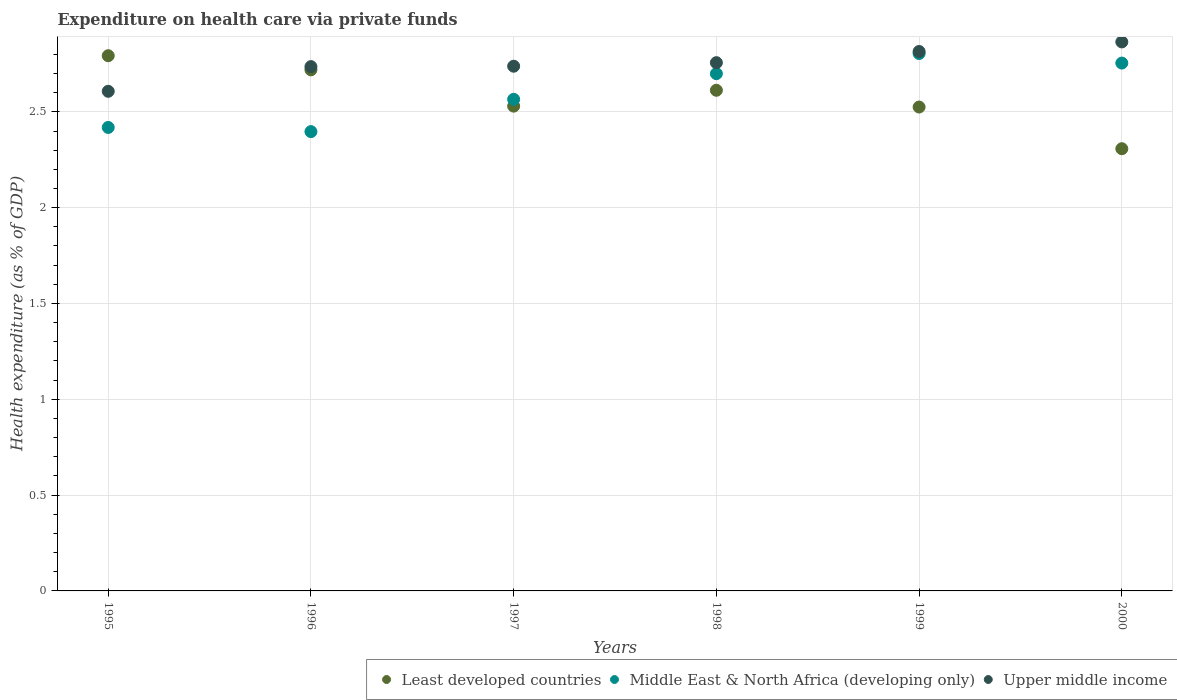What is the expenditure made on health care in Least developed countries in 1997?
Your answer should be compact. 2.53. Across all years, what is the maximum expenditure made on health care in Middle East & North Africa (developing only)?
Ensure brevity in your answer.  2.8. Across all years, what is the minimum expenditure made on health care in Upper middle income?
Your answer should be very brief. 2.61. In which year was the expenditure made on health care in Least developed countries maximum?
Offer a terse response. 1995. What is the total expenditure made on health care in Least developed countries in the graph?
Give a very brief answer. 15.49. What is the difference between the expenditure made on health care in Middle East & North Africa (developing only) in 1995 and that in 1997?
Provide a succinct answer. -0.15. What is the difference between the expenditure made on health care in Least developed countries in 1997 and the expenditure made on health care in Upper middle income in 1996?
Provide a succinct answer. -0.21. What is the average expenditure made on health care in Middle East & North Africa (developing only) per year?
Keep it short and to the point. 2.61. In the year 1999, what is the difference between the expenditure made on health care in Least developed countries and expenditure made on health care in Upper middle income?
Ensure brevity in your answer.  -0.29. In how many years, is the expenditure made on health care in Least developed countries greater than 1.3 %?
Ensure brevity in your answer.  6. What is the ratio of the expenditure made on health care in Middle East & North Africa (developing only) in 1996 to that in 2000?
Your answer should be very brief. 0.87. Is the expenditure made on health care in Upper middle income in 1999 less than that in 2000?
Your answer should be very brief. Yes. What is the difference between the highest and the second highest expenditure made on health care in Least developed countries?
Give a very brief answer. 0.07. What is the difference between the highest and the lowest expenditure made on health care in Middle East & North Africa (developing only)?
Your answer should be very brief. 0.41. In how many years, is the expenditure made on health care in Upper middle income greater than the average expenditure made on health care in Upper middle income taken over all years?
Offer a terse response. 3. Is it the case that in every year, the sum of the expenditure made on health care in Upper middle income and expenditure made on health care in Middle East & North Africa (developing only)  is greater than the expenditure made on health care in Least developed countries?
Your answer should be compact. Yes. Does the expenditure made on health care in Least developed countries monotonically increase over the years?
Your answer should be compact. No. How many years are there in the graph?
Your response must be concise. 6. Are the values on the major ticks of Y-axis written in scientific E-notation?
Provide a succinct answer. No. Does the graph contain any zero values?
Keep it short and to the point. No. Does the graph contain grids?
Offer a terse response. Yes. Where does the legend appear in the graph?
Keep it short and to the point. Bottom right. How many legend labels are there?
Your answer should be very brief. 3. How are the legend labels stacked?
Keep it short and to the point. Horizontal. What is the title of the graph?
Ensure brevity in your answer.  Expenditure on health care via private funds. What is the label or title of the X-axis?
Ensure brevity in your answer.  Years. What is the label or title of the Y-axis?
Your answer should be compact. Health expenditure (as % of GDP). What is the Health expenditure (as % of GDP) of Least developed countries in 1995?
Make the answer very short. 2.79. What is the Health expenditure (as % of GDP) of Middle East & North Africa (developing only) in 1995?
Give a very brief answer. 2.42. What is the Health expenditure (as % of GDP) of Upper middle income in 1995?
Your answer should be compact. 2.61. What is the Health expenditure (as % of GDP) of Least developed countries in 1996?
Keep it short and to the point. 2.72. What is the Health expenditure (as % of GDP) of Middle East & North Africa (developing only) in 1996?
Your answer should be compact. 2.4. What is the Health expenditure (as % of GDP) of Upper middle income in 1996?
Provide a succinct answer. 2.74. What is the Health expenditure (as % of GDP) in Least developed countries in 1997?
Ensure brevity in your answer.  2.53. What is the Health expenditure (as % of GDP) in Middle East & North Africa (developing only) in 1997?
Make the answer very short. 2.57. What is the Health expenditure (as % of GDP) in Upper middle income in 1997?
Your response must be concise. 2.74. What is the Health expenditure (as % of GDP) of Least developed countries in 1998?
Provide a short and direct response. 2.61. What is the Health expenditure (as % of GDP) in Middle East & North Africa (developing only) in 1998?
Offer a very short reply. 2.7. What is the Health expenditure (as % of GDP) of Upper middle income in 1998?
Give a very brief answer. 2.76. What is the Health expenditure (as % of GDP) in Least developed countries in 1999?
Your answer should be compact. 2.53. What is the Health expenditure (as % of GDP) of Middle East & North Africa (developing only) in 1999?
Provide a succinct answer. 2.8. What is the Health expenditure (as % of GDP) in Upper middle income in 1999?
Make the answer very short. 2.81. What is the Health expenditure (as % of GDP) in Least developed countries in 2000?
Keep it short and to the point. 2.31. What is the Health expenditure (as % of GDP) of Middle East & North Africa (developing only) in 2000?
Make the answer very short. 2.75. What is the Health expenditure (as % of GDP) of Upper middle income in 2000?
Give a very brief answer. 2.86. Across all years, what is the maximum Health expenditure (as % of GDP) in Least developed countries?
Your answer should be compact. 2.79. Across all years, what is the maximum Health expenditure (as % of GDP) in Middle East & North Africa (developing only)?
Your answer should be very brief. 2.8. Across all years, what is the maximum Health expenditure (as % of GDP) in Upper middle income?
Your answer should be compact. 2.86. Across all years, what is the minimum Health expenditure (as % of GDP) in Least developed countries?
Offer a very short reply. 2.31. Across all years, what is the minimum Health expenditure (as % of GDP) of Middle East & North Africa (developing only)?
Your answer should be very brief. 2.4. Across all years, what is the minimum Health expenditure (as % of GDP) of Upper middle income?
Provide a succinct answer. 2.61. What is the total Health expenditure (as % of GDP) of Least developed countries in the graph?
Give a very brief answer. 15.49. What is the total Health expenditure (as % of GDP) in Middle East & North Africa (developing only) in the graph?
Offer a very short reply. 15.64. What is the total Health expenditure (as % of GDP) of Upper middle income in the graph?
Keep it short and to the point. 16.52. What is the difference between the Health expenditure (as % of GDP) of Least developed countries in 1995 and that in 1996?
Your answer should be very brief. 0.07. What is the difference between the Health expenditure (as % of GDP) in Middle East & North Africa (developing only) in 1995 and that in 1996?
Make the answer very short. 0.02. What is the difference between the Health expenditure (as % of GDP) in Upper middle income in 1995 and that in 1996?
Provide a short and direct response. -0.13. What is the difference between the Health expenditure (as % of GDP) in Least developed countries in 1995 and that in 1997?
Make the answer very short. 0.26. What is the difference between the Health expenditure (as % of GDP) in Middle East & North Africa (developing only) in 1995 and that in 1997?
Give a very brief answer. -0.15. What is the difference between the Health expenditure (as % of GDP) of Upper middle income in 1995 and that in 1997?
Provide a succinct answer. -0.13. What is the difference between the Health expenditure (as % of GDP) in Least developed countries in 1995 and that in 1998?
Your answer should be very brief. 0.18. What is the difference between the Health expenditure (as % of GDP) in Middle East & North Africa (developing only) in 1995 and that in 1998?
Offer a very short reply. -0.28. What is the difference between the Health expenditure (as % of GDP) in Upper middle income in 1995 and that in 1998?
Your response must be concise. -0.15. What is the difference between the Health expenditure (as % of GDP) of Least developed countries in 1995 and that in 1999?
Provide a succinct answer. 0.27. What is the difference between the Health expenditure (as % of GDP) of Middle East & North Africa (developing only) in 1995 and that in 1999?
Keep it short and to the point. -0.39. What is the difference between the Health expenditure (as % of GDP) in Upper middle income in 1995 and that in 1999?
Give a very brief answer. -0.21. What is the difference between the Health expenditure (as % of GDP) of Least developed countries in 1995 and that in 2000?
Ensure brevity in your answer.  0.49. What is the difference between the Health expenditure (as % of GDP) of Middle East & North Africa (developing only) in 1995 and that in 2000?
Your answer should be compact. -0.34. What is the difference between the Health expenditure (as % of GDP) in Upper middle income in 1995 and that in 2000?
Your answer should be very brief. -0.26. What is the difference between the Health expenditure (as % of GDP) of Least developed countries in 1996 and that in 1997?
Keep it short and to the point. 0.19. What is the difference between the Health expenditure (as % of GDP) of Middle East & North Africa (developing only) in 1996 and that in 1997?
Your answer should be compact. -0.17. What is the difference between the Health expenditure (as % of GDP) of Upper middle income in 1996 and that in 1997?
Keep it short and to the point. -0. What is the difference between the Health expenditure (as % of GDP) in Least developed countries in 1996 and that in 1998?
Provide a succinct answer. 0.11. What is the difference between the Health expenditure (as % of GDP) in Middle East & North Africa (developing only) in 1996 and that in 1998?
Give a very brief answer. -0.3. What is the difference between the Health expenditure (as % of GDP) of Upper middle income in 1996 and that in 1998?
Provide a succinct answer. -0.02. What is the difference between the Health expenditure (as % of GDP) in Least developed countries in 1996 and that in 1999?
Provide a short and direct response. 0.19. What is the difference between the Health expenditure (as % of GDP) of Middle East & North Africa (developing only) in 1996 and that in 1999?
Your answer should be very brief. -0.41. What is the difference between the Health expenditure (as % of GDP) of Upper middle income in 1996 and that in 1999?
Offer a very short reply. -0.08. What is the difference between the Health expenditure (as % of GDP) of Least developed countries in 1996 and that in 2000?
Provide a short and direct response. 0.41. What is the difference between the Health expenditure (as % of GDP) in Middle East & North Africa (developing only) in 1996 and that in 2000?
Provide a short and direct response. -0.36. What is the difference between the Health expenditure (as % of GDP) in Upper middle income in 1996 and that in 2000?
Your response must be concise. -0.13. What is the difference between the Health expenditure (as % of GDP) of Least developed countries in 1997 and that in 1998?
Your answer should be very brief. -0.08. What is the difference between the Health expenditure (as % of GDP) of Middle East & North Africa (developing only) in 1997 and that in 1998?
Keep it short and to the point. -0.13. What is the difference between the Health expenditure (as % of GDP) of Upper middle income in 1997 and that in 1998?
Your answer should be compact. -0.02. What is the difference between the Health expenditure (as % of GDP) of Least developed countries in 1997 and that in 1999?
Your answer should be compact. 0. What is the difference between the Health expenditure (as % of GDP) in Middle East & North Africa (developing only) in 1997 and that in 1999?
Provide a short and direct response. -0.24. What is the difference between the Health expenditure (as % of GDP) of Upper middle income in 1997 and that in 1999?
Give a very brief answer. -0.08. What is the difference between the Health expenditure (as % of GDP) in Least developed countries in 1997 and that in 2000?
Offer a very short reply. 0.22. What is the difference between the Health expenditure (as % of GDP) in Middle East & North Africa (developing only) in 1997 and that in 2000?
Make the answer very short. -0.19. What is the difference between the Health expenditure (as % of GDP) of Upper middle income in 1997 and that in 2000?
Provide a short and direct response. -0.13. What is the difference between the Health expenditure (as % of GDP) in Least developed countries in 1998 and that in 1999?
Ensure brevity in your answer.  0.09. What is the difference between the Health expenditure (as % of GDP) in Middle East & North Africa (developing only) in 1998 and that in 1999?
Keep it short and to the point. -0.11. What is the difference between the Health expenditure (as % of GDP) in Upper middle income in 1998 and that in 1999?
Provide a succinct answer. -0.06. What is the difference between the Health expenditure (as % of GDP) in Least developed countries in 1998 and that in 2000?
Give a very brief answer. 0.3. What is the difference between the Health expenditure (as % of GDP) of Middle East & North Africa (developing only) in 1998 and that in 2000?
Provide a succinct answer. -0.06. What is the difference between the Health expenditure (as % of GDP) of Upper middle income in 1998 and that in 2000?
Make the answer very short. -0.11. What is the difference between the Health expenditure (as % of GDP) of Least developed countries in 1999 and that in 2000?
Offer a terse response. 0.22. What is the difference between the Health expenditure (as % of GDP) in Middle East & North Africa (developing only) in 1999 and that in 2000?
Your answer should be very brief. 0.05. What is the difference between the Health expenditure (as % of GDP) of Least developed countries in 1995 and the Health expenditure (as % of GDP) of Middle East & North Africa (developing only) in 1996?
Your answer should be compact. 0.4. What is the difference between the Health expenditure (as % of GDP) of Least developed countries in 1995 and the Health expenditure (as % of GDP) of Upper middle income in 1996?
Provide a succinct answer. 0.06. What is the difference between the Health expenditure (as % of GDP) in Middle East & North Africa (developing only) in 1995 and the Health expenditure (as % of GDP) in Upper middle income in 1996?
Your response must be concise. -0.32. What is the difference between the Health expenditure (as % of GDP) in Least developed countries in 1995 and the Health expenditure (as % of GDP) in Middle East & North Africa (developing only) in 1997?
Ensure brevity in your answer.  0.23. What is the difference between the Health expenditure (as % of GDP) of Least developed countries in 1995 and the Health expenditure (as % of GDP) of Upper middle income in 1997?
Make the answer very short. 0.05. What is the difference between the Health expenditure (as % of GDP) in Middle East & North Africa (developing only) in 1995 and the Health expenditure (as % of GDP) in Upper middle income in 1997?
Make the answer very short. -0.32. What is the difference between the Health expenditure (as % of GDP) in Least developed countries in 1995 and the Health expenditure (as % of GDP) in Middle East & North Africa (developing only) in 1998?
Your response must be concise. 0.09. What is the difference between the Health expenditure (as % of GDP) in Least developed countries in 1995 and the Health expenditure (as % of GDP) in Upper middle income in 1998?
Offer a very short reply. 0.04. What is the difference between the Health expenditure (as % of GDP) in Middle East & North Africa (developing only) in 1995 and the Health expenditure (as % of GDP) in Upper middle income in 1998?
Offer a very short reply. -0.34. What is the difference between the Health expenditure (as % of GDP) in Least developed countries in 1995 and the Health expenditure (as % of GDP) in Middle East & North Africa (developing only) in 1999?
Your answer should be very brief. -0.01. What is the difference between the Health expenditure (as % of GDP) of Least developed countries in 1995 and the Health expenditure (as % of GDP) of Upper middle income in 1999?
Your answer should be compact. -0.02. What is the difference between the Health expenditure (as % of GDP) in Middle East & North Africa (developing only) in 1995 and the Health expenditure (as % of GDP) in Upper middle income in 1999?
Provide a short and direct response. -0.4. What is the difference between the Health expenditure (as % of GDP) in Least developed countries in 1995 and the Health expenditure (as % of GDP) in Middle East & North Africa (developing only) in 2000?
Provide a short and direct response. 0.04. What is the difference between the Health expenditure (as % of GDP) in Least developed countries in 1995 and the Health expenditure (as % of GDP) in Upper middle income in 2000?
Make the answer very short. -0.07. What is the difference between the Health expenditure (as % of GDP) of Middle East & North Africa (developing only) in 1995 and the Health expenditure (as % of GDP) of Upper middle income in 2000?
Keep it short and to the point. -0.45. What is the difference between the Health expenditure (as % of GDP) in Least developed countries in 1996 and the Health expenditure (as % of GDP) in Middle East & North Africa (developing only) in 1997?
Provide a short and direct response. 0.15. What is the difference between the Health expenditure (as % of GDP) of Least developed countries in 1996 and the Health expenditure (as % of GDP) of Upper middle income in 1997?
Offer a terse response. -0.02. What is the difference between the Health expenditure (as % of GDP) in Middle East & North Africa (developing only) in 1996 and the Health expenditure (as % of GDP) in Upper middle income in 1997?
Offer a terse response. -0.34. What is the difference between the Health expenditure (as % of GDP) of Least developed countries in 1996 and the Health expenditure (as % of GDP) of Middle East & North Africa (developing only) in 1998?
Provide a short and direct response. 0.02. What is the difference between the Health expenditure (as % of GDP) of Least developed countries in 1996 and the Health expenditure (as % of GDP) of Upper middle income in 1998?
Ensure brevity in your answer.  -0.04. What is the difference between the Health expenditure (as % of GDP) of Middle East & North Africa (developing only) in 1996 and the Health expenditure (as % of GDP) of Upper middle income in 1998?
Give a very brief answer. -0.36. What is the difference between the Health expenditure (as % of GDP) in Least developed countries in 1996 and the Health expenditure (as % of GDP) in Middle East & North Africa (developing only) in 1999?
Keep it short and to the point. -0.09. What is the difference between the Health expenditure (as % of GDP) in Least developed countries in 1996 and the Health expenditure (as % of GDP) in Upper middle income in 1999?
Your answer should be compact. -0.1. What is the difference between the Health expenditure (as % of GDP) in Middle East & North Africa (developing only) in 1996 and the Health expenditure (as % of GDP) in Upper middle income in 1999?
Make the answer very short. -0.42. What is the difference between the Health expenditure (as % of GDP) of Least developed countries in 1996 and the Health expenditure (as % of GDP) of Middle East & North Africa (developing only) in 2000?
Give a very brief answer. -0.04. What is the difference between the Health expenditure (as % of GDP) of Least developed countries in 1996 and the Health expenditure (as % of GDP) of Upper middle income in 2000?
Ensure brevity in your answer.  -0.15. What is the difference between the Health expenditure (as % of GDP) in Middle East & North Africa (developing only) in 1996 and the Health expenditure (as % of GDP) in Upper middle income in 2000?
Provide a short and direct response. -0.47. What is the difference between the Health expenditure (as % of GDP) of Least developed countries in 1997 and the Health expenditure (as % of GDP) of Middle East & North Africa (developing only) in 1998?
Keep it short and to the point. -0.17. What is the difference between the Health expenditure (as % of GDP) in Least developed countries in 1997 and the Health expenditure (as % of GDP) in Upper middle income in 1998?
Make the answer very short. -0.23. What is the difference between the Health expenditure (as % of GDP) in Middle East & North Africa (developing only) in 1997 and the Health expenditure (as % of GDP) in Upper middle income in 1998?
Make the answer very short. -0.19. What is the difference between the Health expenditure (as % of GDP) in Least developed countries in 1997 and the Health expenditure (as % of GDP) in Middle East & North Africa (developing only) in 1999?
Your response must be concise. -0.27. What is the difference between the Health expenditure (as % of GDP) of Least developed countries in 1997 and the Health expenditure (as % of GDP) of Upper middle income in 1999?
Your response must be concise. -0.29. What is the difference between the Health expenditure (as % of GDP) of Middle East & North Africa (developing only) in 1997 and the Health expenditure (as % of GDP) of Upper middle income in 1999?
Make the answer very short. -0.25. What is the difference between the Health expenditure (as % of GDP) of Least developed countries in 1997 and the Health expenditure (as % of GDP) of Middle East & North Africa (developing only) in 2000?
Provide a succinct answer. -0.22. What is the difference between the Health expenditure (as % of GDP) of Least developed countries in 1997 and the Health expenditure (as % of GDP) of Upper middle income in 2000?
Keep it short and to the point. -0.34. What is the difference between the Health expenditure (as % of GDP) of Middle East & North Africa (developing only) in 1997 and the Health expenditure (as % of GDP) of Upper middle income in 2000?
Provide a short and direct response. -0.3. What is the difference between the Health expenditure (as % of GDP) in Least developed countries in 1998 and the Health expenditure (as % of GDP) in Middle East & North Africa (developing only) in 1999?
Provide a succinct answer. -0.19. What is the difference between the Health expenditure (as % of GDP) of Least developed countries in 1998 and the Health expenditure (as % of GDP) of Upper middle income in 1999?
Give a very brief answer. -0.2. What is the difference between the Health expenditure (as % of GDP) of Middle East & North Africa (developing only) in 1998 and the Health expenditure (as % of GDP) of Upper middle income in 1999?
Make the answer very short. -0.12. What is the difference between the Health expenditure (as % of GDP) in Least developed countries in 1998 and the Health expenditure (as % of GDP) in Middle East & North Africa (developing only) in 2000?
Provide a short and direct response. -0.14. What is the difference between the Health expenditure (as % of GDP) in Least developed countries in 1998 and the Health expenditure (as % of GDP) in Upper middle income in 2000?
Offer a very short reply. -0.25. What is the difference between the Health expenditure (as % of GDP) of Middle East & North Africa (developing only) in 1998 and the Health expenditure (as % of GDP) of Upper middle income in 2000?
Provide a short and direct response. -0.17. What is the difference between the Health expenditure (as % of GDP) of Least developed countries in 1999 and the Health expenditure (as % of GDP) of Middle East & North Africa (developing only) in 2000?
Your response must be concise. -0.23. What is the difference between the Health expenditure (as % of GDP) in Least developed countries in 1999 and the Health expenditure (as % of GDP) in Upper middle income in 2000?
Provide a succinct answer. -0.34. What is the difference between the Health expenditure (as % of GDP) in Middle East & North Africa (developing only) in 1999 and the Health expenditure (as % of GDP) in Upper middle income in 2000?
Offer a very short reply. -0.06. What is the average Health expenditure (as % of GDP) of Least developed countries per year?
Provide a short and direct response. 2.58. What is the average Health expenditure (as % of GDP) in Middle East & North Africa (developing only) per year?
Provide a short and direct response. 2.61. What is the average Health expenditure (as % of GDP) in Upper middle income per year?
Make the answer very short. 2.75. In the year 1995, what is the difference between the Health expenditure (as % of GDP) in Least developed countries and Health expenditure (as % of GDP) in Middle East & North Africa (developing only)?
Make the answer very short. 0.37. In the year 1995, what is the difference between the Health expenditure (as % of GDP) in Least developed countries and Health expenditure (as % of GDP) in Upper middle income?
Make the answer very short. 0.19. In the year 1995, what is the difference between the Health expenditure (as % of GDP) in Middle East & North Africa (developing only) and Health expenditure (as % of GDP) in Upper middle income?
Provide a succinct answer. -0.19. In the year 1996, what is the difference between the Health expenditure (as % of GDP) in Least developed countries and Health expenditure (as % of GDP) in Middle East & North Africa (developing only)?
Provide a short and direct response. 0.32. In the year 1996, what is the difference between the Health expenditure (as % of GDP) in Least developed countries and Health expenditure (as % of GDP) in Upper middle income?
Provide a succinct answer. -0.02. In the year 1996, what is the difference between the Health expenditure (as % of GDP) of Middle East & North Africa (developing only) and Health expenditure (as % of GDP) of Upper middle income?
Give a very brief answer. -0.34. In the year 1997, what is the difference between the Health expenditure (as % of GDP) of Least developed countries and Health expenditure (as % of GDP) of Middle East & North Africa (developing only)?
Your response must be concise. -0.04. In the year 1997, what is the difference between the Health expenditure (as % of GDP) of Least developed countries and Health expenditure (as % of GDP) of Upper middle income?
Offer a very short reply. -0.21. In the year 1997, what is the difference between the Health expenditure (as % of GDP) in Middle East & North Africa (developing only) and Health expenditure (as % of GDP) in Upper middle income?
Make the answer very short. -0.17. In the year 1998, what is the difference between the Health expenditure (as % of GDP) in Least developed countries and Health expenditure (as % of GDP) in Middle East & North Africa (developing only)?
Your answer should be compact. -0.09. In the year 1998, what is the difference between the Health expenditure (as % of GDP) in Least developed countries and Health expenditure (as % of GDP) in Upper middle income?
Ensure brevity in your answer.  -0.14. In the year 1998, what is the difference between the Health expenditure (as % of GDP) of Middle East & North Africa (developing only) and Health expenditure (as % of GDP) of Upper middle income?
Provide a short and direct response. -0.06. In the year 1999, what is the difference between the Health expenditure (as % of GDP) of Least developed countries and Health expenditure (as % of GDP) of Middle East & North Africa (developing only)?
Your response must be concise. -0.28. In the year 1999, what is the difference between the Health expenditure (as % of GDP) in Least developed countries and Health expenditure (as % of GDP) in Upper middle income?
Make the answer very short. -0.29. In the year 1999, what is the difference between the Health expenditure (as % of GDP) of Middle East & North Africa (developing only) and Health expenditure (as % of GDP) of Upper middle income?
Make the answer very short. -0.01. In the year 2000, what is the difference between the Health expenditure (as % of GDP) of Least developed countries and Health expenditure (as % of GDP) of Middle East & North Africa (developing only)?
Provide a short and direct response. -0.45. In the year 2000, what is the difference between the Health expenditure (as % of GDP) of Least developed countries and Health expenditure (as % of GDP) of Upper middle income?
Offer a terse response. -0.56. In the year 2000, what is the difference between the Health expenditure (as % of GDP) of Middle East & North Africa (developing only) and Health expenditure (as % of GDP) of Upper middle income?
Give a very brief answer. -0.11. What is the ratio of the Health expenditure (as % of GDP) in Least developed countries in 1995 to that in 1996?
Your answer should be very brief. 1.03. What is the ratio of the Health expenditure (as % of GDP) in Middle East & North Africa (developing only) in 1995 to that in 1996?
Provide a short and direct response. 1.01. What is the ratio of the Health expenditure (as % of GDP) of Upper middle income in 1995 to that in 1996?
Ensure brevity in your answer.  0.95. What is the ratio of the Health expenditure (as % of GDP) of Least developed countries in 1995 to that in 1997?
Offer a very short reply. 1.1. What is the ratio of the Health expenditure (as % of GDP) in Middle East & North Africa (developing only) in 1995 to that in 1997?
Give a very brief answer. 0.94. What is the ratio of the Health expenditure (as % of GDP) of Upper middle income in 1995 to that in 1997?
Provide a succinct answer. 0.95. What is the ratio of the Health expenditure (as % of GDP) of Least developed countries in 1995 to that in 1998?
Offer a very short reply. 1.07. What is the ratio of the Health expenditure (as % of GDP) of Middle East & North Africa (developing only) in 1995 to that in 1998?
Give a very brief answer. 0.9. What is the ratio of the Health expenditure (as % of GDP) in Upper middle income in 1995 to that in 1998?
Give a very brief answer. 0.95. What is the ratio of the Health expenditure (as % of GDP) of Least developed countries in 1995 to that in 1999?
Your answer should be very brief. 1.11. What is the ratio of the Health expenditure (as % of GDP) in Middle East & North Africa (developing only) in 1995 to that in 1999?
Make the answer very short. 0.86. What is the ratio of the Health expenditure (as % of GDP) of Upper middle income in 1995 to that in 1999?
Make the answer very short. 0.93. What is the ratio of the Health expenditure (as % of GDP) of Least developed countries in 1995 to that in 2000?
Your response must be concise. 1.21. What is the ratio of the Health expenditure (as % of GDP) in Middle East & North Africa (developing only) in 1995 to that in 2000?
Your answer should be very brief. 0.88. What is the ratio of the Health expenditure (as % of GDP) of Upper middle income in 1995 to that in 2000?
Make the answer very short. 0.91. What is the ratio of the Health expenditure (as % of GDP) in Least developed countries in 1996 to that in 1997?
Offer a terse response. 1.07. What is the ratio of the Health expenditure (as % of GDP) in Middle East & North Africa (developing only) in 1996 to that in 1997?
Your answer should be very brief. 0.93. What is the ratio of the Health expenditure (as % of GDP) in Least developed countries in 1996 to that in 1998?
Your answer should be compact. 1.04. What is the ratio of the Health expenditure (as % of GDP) in Middle East & North Africa (developing only) in 1996 to that in 1998?
Keep it short and to the point. 0.89. What is the ratio of the Health expenditure (as % of GDP) in Middle East & North Africa (developing only) in 1996 to that in 1999?
Your answer should be very brief. 0.85. What is the ratio of the Health expenditure (as % of GDP) in Upper middle income in 1996 to that in 1999?
Your answer should be compact. 0.97. What is the ratio of the Health expenditure (as % of GDP) of Least developed countries in 1996 to that in 2000?
Offer a terse response. 1.18. What is the ratio of the Health expenditure (as % of GDP) of Middle East & North Africa (developing only) in 1996 to that in 2000?
Your answer should be very brief. 0.87. What is the ratio of the Health expenditure (as % of GDP) in Upper middle income in 1996 to that in 2000?
Your response must be concise. 0.95. What is the ratio of the Health expenditure (as % of GDP) of Least developed countries in 1997 to that in 1998?
Make the answer very short. 0.97. What is the ratio of the Health expenditure (as % of GDP) in Middle East & North Africa (developing only) in 1997 to that in 1998?
Ensure brevity in your answer.  0.95. What is the ratio of the Health expenditure (as % of GDP) of Least developed countries in 1997 to that in 1999?
Keep it short and to the point. 1. What is the ratio of the Health expenditure (as % of GDP) of Middle East & North Africa (developing only) in 1997 to that in 1999?
Make the answer very short. 0.91. What is the ratio of the Health expenditure (as % of GDP) in Upper middle income in 1997 to that in 1999?
Your response must be concise. 0.97. What is the ratio of the Health expenditure (as % of GDP) of Least developed countries in 1997 to that in 2000?
Ensure brevity in your answer.  1.1. What is the ratio of the Health expenditure (as % of GDP) in Middle East & North Africa (developing only) in 1997 to that in 2000?
Keep it short and to the point. 0.93. What is the ratio of the Health expenditure (as % of GDP) of Upper middle income in 1997 to that in 2000?
Keep it short and to the point. 0.96. What is the ratio of the Health expenditure (as % of GDP) of Least developed countries in 1998 to that in 1999?
Offer a very short reply. 1.03. What is the ratio of the Health expenditure (as % of GDP) in Middle East & North Africa (developing only) in 1998 to that in 1999?
Your answer should be compact. 0.96. What is the ratio of the Health expenditure (as % of GDP) in Upper middle income in 1998 to that in 1999?
Ensure brevity in your answer.  0.98. What is the ratio of the Health expenditure (as % of GDP) of Least developed countries in 1998 to that in 2000?
Your answer should be compact. 1.13. What is the ratio of the Health expenditure (as % of GDP) in Middle East & North Africa (developing only) in 1998 to that in 2000?
Ensure brevity in your answer.  0.98. What is the ratio of the Health expenditure (as % of GDP) in Upper middle income in 1998 to that in 2000?
Provide a short and direct response. 0.96. What is the ratio of the Health expenditure (as % of GDP) of Least developed countries in 1999 to that in 2000?
Your response must be concise. 1.09. What is the ratio of the Health expenditure (as % of GDP) of Middle East & North Africa (developing only) in 1999 to that in 2000?
Your answer should be compact. 1.02. What is the ratio of the Health expenditure (as % of GDP) in Upper middle income in 1999 to that in 2000?
Keep it short and to the point. 0.98. What is the difference between the highest and the second highest Health expenditure (as % of GDP) in Least developed countries?
Your response must be concise. 0.07. What is the difference between the highest and the second highest Health expenditure (as % of GDP) of Middle East & North Africa (developing only)?
Offer a very short reply. 0.05. What is the difference between the highest and the second highest Health expenditure (as % of GDP) in Upper middle income?
Provide a short and direct response. 0.05. What is the difference between the highest and the lowest Health expenditure (as % of GDP) in Least developed countries?
Provide a short and direct response. 0.49. What is the difference between the highest and the lowest Health expenditure (as % of GDP) in Middle East & North Africa (developing only)?
Your answer should be compact. 0.41. What is the difference between the highest and the lowest Health expenditure (as % of GDP) of Upper middle income?
Make the answer very short. 0.26. 